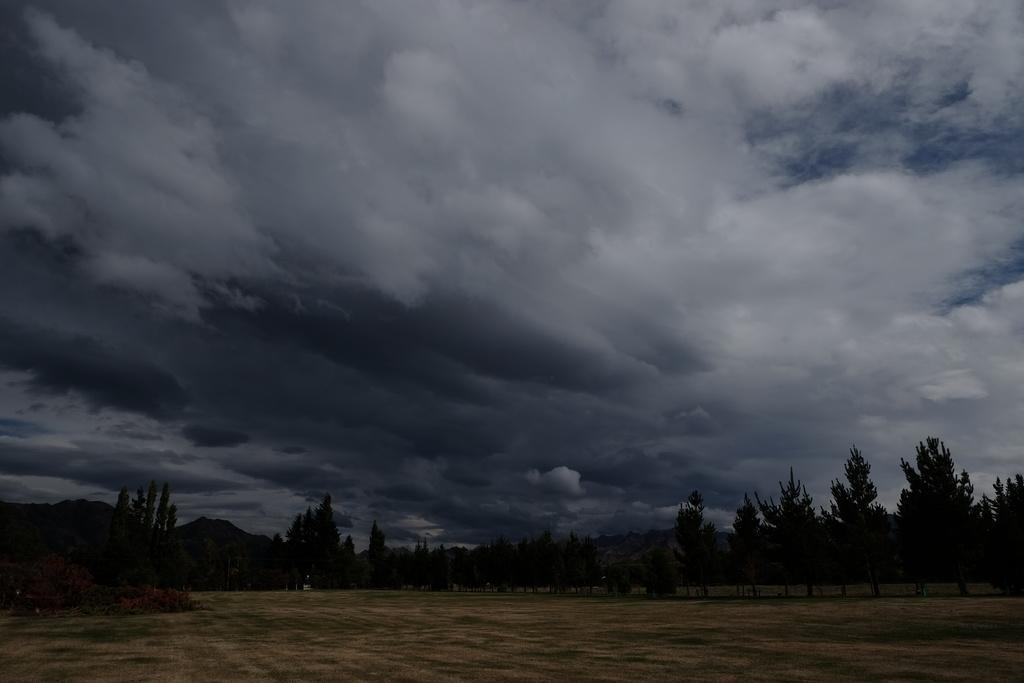In one or two sentences, can you explain what this image depicts? In this image we can see trees, grass, sky and clouds. 